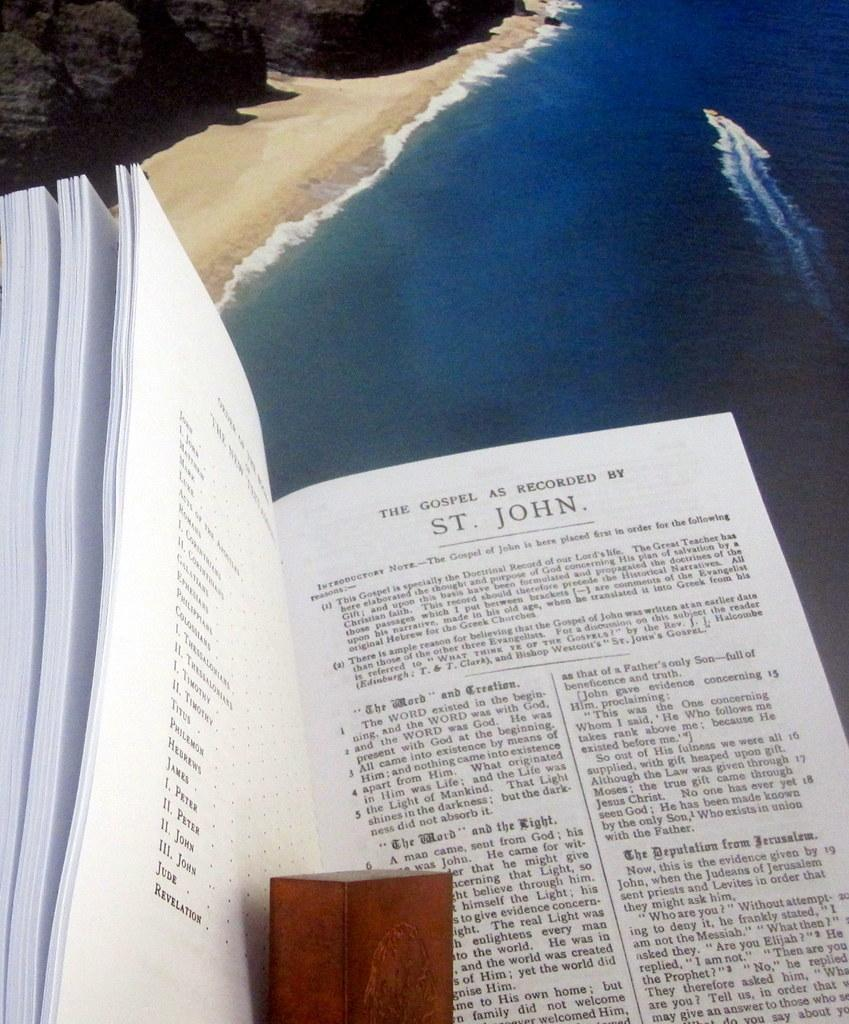<image>
Summarize the visual content of the image. a book that has the title on a page that says 'the gospel as recorded by st. john.' 